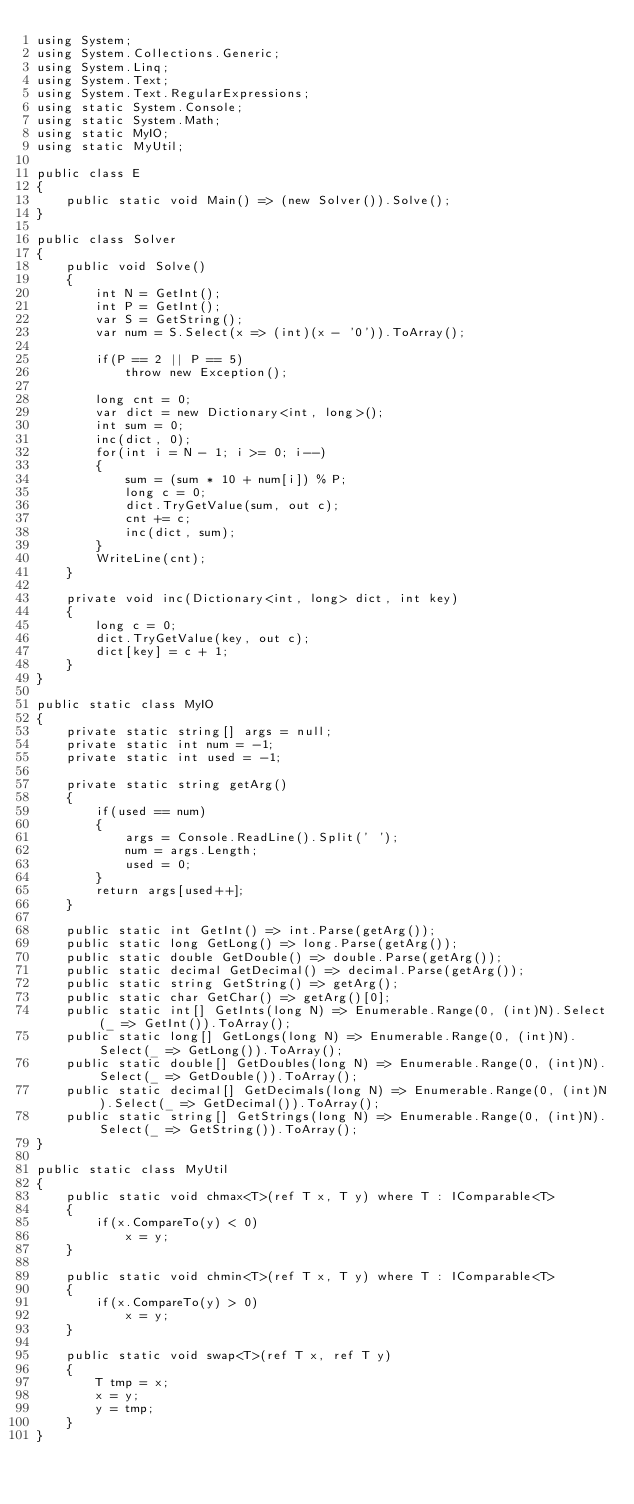<code> <loc_0><loc_0><loc_500><loc_500><_C#_>using System;
using System.Collections.Generic;
using System.Linq;
using System.Text;
using System.Text.RegularExpressions;
using static System.Console;
using static System.Math;
using static MyIO;
using static MyUtil;

public class E
{
	public static void Main() => (new Solver()).Solve();
}

public class Solver
{
	public void Solve()
	{
		int N = GetInt();
		int P = GetInt();
		var S = GetString();
		var num = S.Select(x => (int)(x - '0')).ToArray();

		if(P == 2 || P == 5)
			throw new Exception();

		long cnt = 0;
		var dict = new Dictionary<int, long>();
		int sum = 0;
		inc(dict, 0);
		for(int i = N - 1; i >= 0; i--)
		{
			sum = (sum * 10 + num[i]) % P;
			long c = 0;
			dict.TryGetValue(sum, out c);
			cnt += c;
			inc(dict, sum);
		}
		WriteLine(cnt);
	}

	private void inc(Dictionary<int, long> dict, int key)
	{
		long c = 0;
		dict.TryGetValue(key, out c);
		dict[key] = c + 1;
	}
}

public static class MyIO
{
	private static string[] args = null;
	private static int num = -1;
	private static int used = -1;

	private static string getArg()
	{
		if(used == num)
		{
			args = Console.ReadLine().Split(' ');
			num = args.Length;
			used = 0;
		}
		return args[used++];
	}

	public static int GetInt() => int.Parse(getArg());
	public static long GetLong() => long.Parse(getArg());
	public static double GetDouble() => double.Parse(getArg());
	public static decimal GetDecimal() => decimal.Parse(getArg());
	public static string GetString() => getArg();
	public static char GetChar() => getArg()[0];
	public static int[] GetInts(long N) => Enumerable.Range(0, (int)N).Select(_ => GetInt()).ToArray();
	public static long[] GetLongs(long N) => Enumerable.Range(0, (int)N).Select(_ => GetLong()).ToArray();
	public static double[] GetDoubles(long N) => Enumerable.Range(0, (int)N).Select(_ => GetDouble()).ToArray();
	public static decimal[] GetDecimals(long N) => Enumerable.Range(0, (int)N).Select(_ => GetDecimal()).ToArray();
	public static string[] GetStrings(long N) => Enumerable.Range(0, (int)N).Select(_ => GetString()).ToArray();
}

public static class MyUtil
{
	public static void chmax<T>(ref T x, T y) where T : IComparable<T>
	{
		if(x.CompareTo(y) < 0)
			x = y;
	}

	public static void chmin<T>(ref T x, T y) where T : IComparable<T>
	{
		if(x.CompareTo(y) > 0)
			x = y;
	}

	public static void swap<T>(ref T x, ref T y)
	{
		T tmp = x;
		x = y;
		y = tmp;
	}
}</code> 